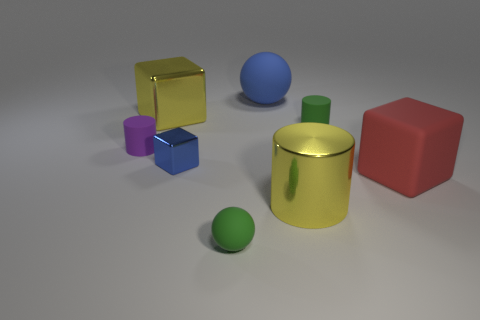Add 2 big things. How many objects exist? 10 Subtract all blocks. How many objects are left? 5 Subtract 0 cyan cylinders. How many objects are left? 8 Subtract all tiny green shiny objects. Subtract all blue cubes. How many objects are left? 7 Add 7 red rubber cubes. How many red rubber cubes are left? 8 Add 4 tiny purple things. How many tiny purple things exist? 5 